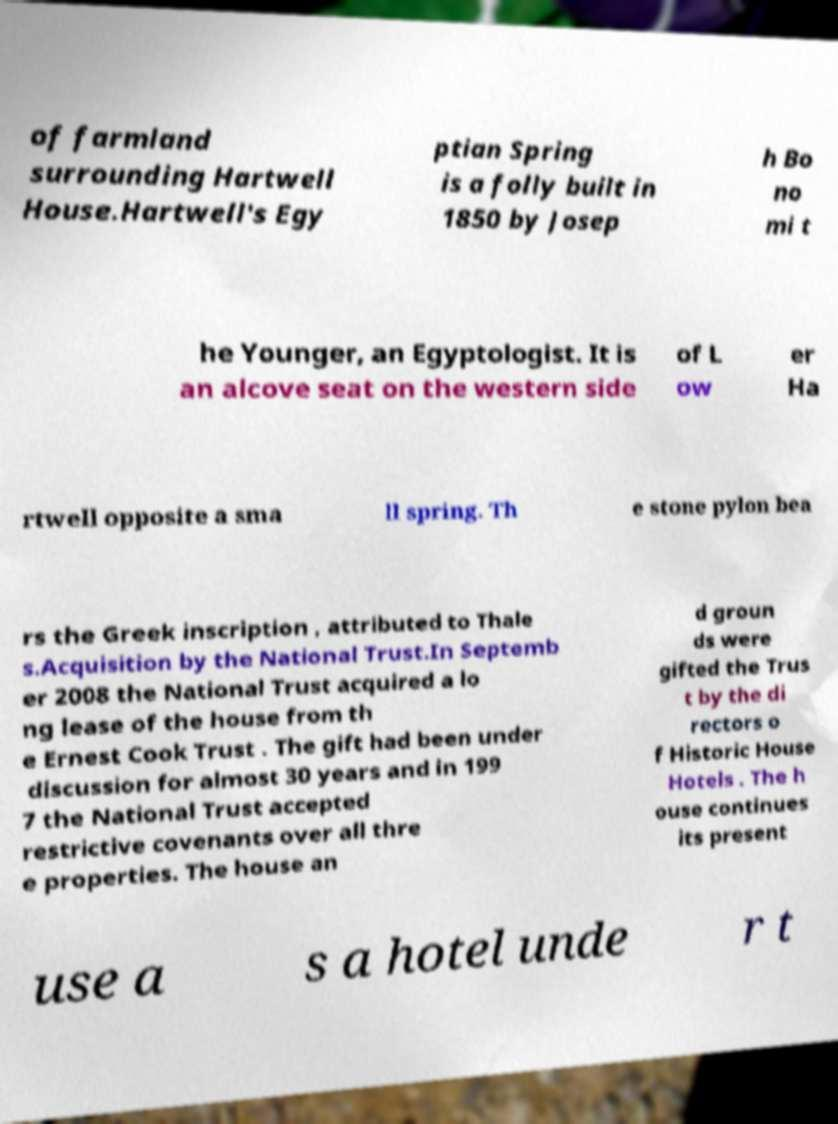I need the written content from this picture converted into text. Can you do that? of farmland surrounding Hartwell House.Hartwell's Egy ptian Spring is a folly built in 1850 by Josep h Bo no mi t he Younger, an Egyptologist. It is an alcove seat on the western side of L ow er Ha rtwell opposite a sma ll spring. Th e stone pylon bea rs the Greek inscription , attributed to Thale s.Acquisition by the National Trust.In Septemb er 2008 the National Trust acquired a lo ng lease of the house from th e Ernest Cook Trust . The gift had been under discussion for almost 30 years and in 199 7 the National Trust accepted restrictive covenants over all thre e properties. The house an d groun ds were gifted the Trus t by the di rectors o f Historic House Hotels . The h ouse continues its present use a s a hotel unde r t 